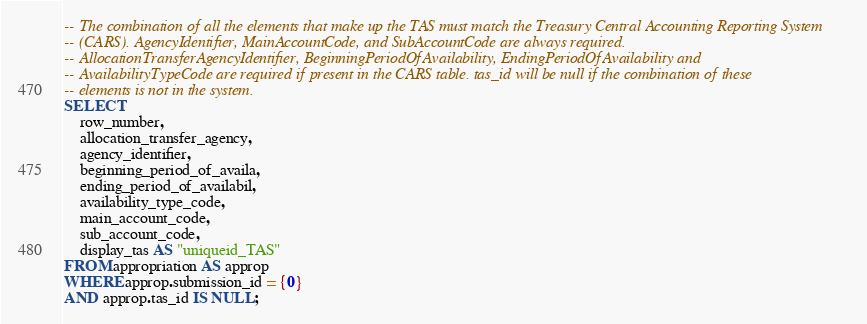Convert code to text. <code><loc_0><loc_0><loc_500><loc_500><_SQL_>-- The combination of all the elements that make up the TAS must match the Treasury Central Accounting Reporting System
-- (CARS). AgencyIdentifier, MainAccountCode, and SubAccountCode are always required.
-- AllocationTransferAgencyIdentifier, BeginningPeriodOfAvailability, EndingPeriodOfAvailability and
-- AvailabilityTypeCode are required if present in the CARS table. tas_id will be null if the combination of these
-- elements is not in the system.
SELECT
    row_number,
    allocation_transfer_agency,
    agency_identifier,
    beginning_period_of_availa,
    ending_period_of_availabil,
    availability_type_code,
    main_account_code,
    sub_account_code,
    display_tas AS "uniqueid_TAS"
FROM appropriation AS approp
WHERE approp.submission_id = {0}
AND approp.tas_id IS NULL;
</code> 